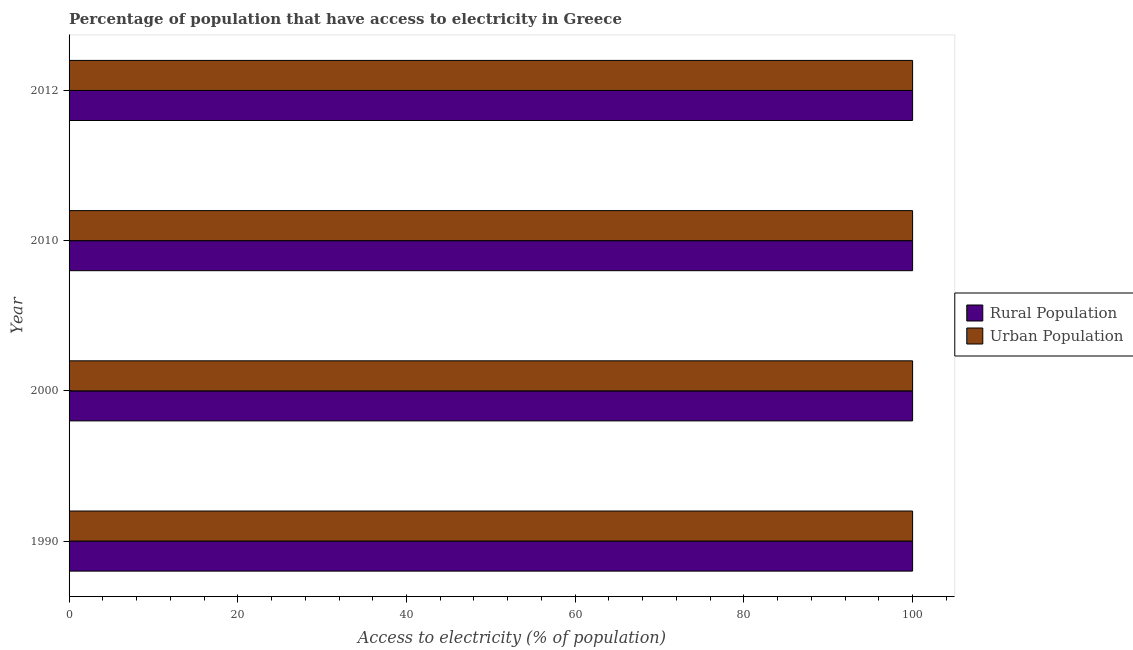How many different coloured bars are there?
Make the answer very short. 2. What is the percentage of rural population having access to electricity in 2012?
Provide a short and direct response. 100. Across all years, what is the maximum percentage of urban population having access to electricity?
Provide a short and direct response. 100. Across all years, what is the minimum percentage of rural population having access to electricity?
Your answer should be very brief. 100. What is the total percentage of rural population having access to electricity in the graph?
Keep it short and to the point. 400. What is the difference between the percentage of urban population having access to electricity in 1990 and that in 2010?
Offer a terse response. 0. What is the difference between the percentage of rural population having access to electricity in 2010 and the percentage of urban population having access to electricity in 1990?
Give a very brief answer. 0. What is the average percentage of rural population having access to electricity per year?
Provide a short and direct response. 100. In the year 1990, what is the difference between the percentage of rural population having access to electricity and percentage of urban population having access to electricity?
Make the answer very short. 0. In how many years, is the percentage of rural population having access to electricity greater than 72 %?
Make the answer very short. 4. What is the ratio of the percentage of rural population having access to electricity in 1990 to that in 2012?
Offer a very short reply. 1. What does the 1st bar from the top in 2010 represents?
Your answer should be very brief. Urban Population. What does the 2nd bar from the bottom in 1990 represents?
Your response must be concise. Urban Population. Are all the bars in the graph horizontal?
Offer a very short reply. Yes. How many years are there in the graph?
Your response must be concise. 4. What is the difference between two consecutive major ticks on the X-axis?
Offer a very short reply. 20. Are the values on the major ticks of X-axis written in scientific E-notation?
Your answer should be very brief. No. Does the graph contain any zero values?
Your answer should be very brief. No. Does the graph contain grids?
Ensure brevity in your answer.  No. Where does the legend appear in the graph?
Provide a short and direct response. Center right. How many legend labels are there?
Give a very brief answer. 2. What is the title of the graph?
Offer a very short reply. Percentage of population that have access to electricity in Greece. Does "Electricity" appear as one of the legend labels in the graph?
Offer a very short reply. No. What is the label or title of the X-axis?
Ensure brevity in your answer.  Access to electricity (% of population). What is the label or title of the Y-axis?
Keep it short and to the point. Year. What is the Access to electricity (% of population) of Rural Population in 2010?
Your answer should be compact. 100. What is the Access to electricity (% of population) in Rural Population in 2012?
Offer a terse response. 100. What is the Access to electricity (% of population) of Urban Population in 2012?
Your answer should be very brief. 100. Across all years, what is the maximum Access to electricity (% of population) in Rural Population?
Your response must be concise. 100. What is the total Access to electricity (% of population) of Rural Population in the graph?
Keep it short and to the point. 400. What is the difference between the Access to electricity (% of population) in Rural Population in 1990 and that in 2000?
Ensure brevity in your answer.  0. What is the difference between the Access to electricity (% of population) of Urban Population in 1990 and that in 2000?
Provide a short and direct response. 0. What is the difference between the Access to electricity (% of population) of Rural Population in 1990 and that in 2010?
Ensure brevity in your answer.  0. What is the difference between the Access to electricity (% of population) of Urban Population in 1990 and that in 2012?
Make the answer very short. 0. What is the difference between the Access to electricity (% of population) in Urban Population in 2000 and that in 2010?
Your answer should be very brief. 0. What is the difference between the Access to electricity (% of population) in Rural Population in 2000 and that in 2012?
Your response must be concise. 0. What is the difference between the Access to electricity (% of population) in Rural Population in 2010 and that in 2012?
Keep it short and to the point. 0. What is the difference between the Access to electricity (% of population) in Urban Population in 2010 and that in 2012?
Your response must be concise. 0. What is the difference between the Access to electricity (% of population) in Rural Population in 1990 and the Access to electricity (% of population) in Urban Population in 2010?
Give a very brief answer. 0. What is the difference between the Access to electricity (% of population) in Rural Population in 2000 and the Access to electricity (% of population) in Urban Population in 2010?
Ensure brevity in your answer.  0. What is the difference between the Access to electricity (% of population) of Rural Population in 2010 and the Access to electricity (% of population) of Urban Population in 2012?
Keep it short and to the point. 0. What is the average Access to electricity (% of population) of Rural Population per year?
Give a very brief answer. 100. What is the average Access to electricity (% of population) of Urban Population per year?
Make the answer very short. 100. In the year 1990, what is the difference between the Access to electricity (% of population) in Rural Population and Access to electricity (% of population) in Urban Population?
Offer a terse response. 0. In the year 2000, what is the difference between the Access to electricity (% of population) in Rural Population and Access to electricity (% of population) in Urban Population?
Provide a short and direct response. 0. In the year 2012, what is the difference between the Access to electricity (% of population) in Rural Population and Access to electricity (% of population) in Urban Population?
Provide a short and direct response. 0. What is the ratio of the Access to electricity (% of population) of Rural Population in 1990 to that in 2000?
Make the answer very short. 1. What is the ratio of the Access to electricity (% of population) in Urban Population in 1990 to that in 2010?
Your answer should be very brief. 1. What is the ratio of the Access to electricity (% of population) of Rural Population in 1990 to that in 2012?
Keep it short and to the point. 1. What is the ratio of the Access to electricity (% of population) of Rural Population in 2000 to that in 2010?
Give a very brief answer. 1. What is the ratio of the Access to electricity (% of population) in Urban Population in 2000 to that in 2010?
Keep it short and to the point. 1. What is the ratio of the Access to electricity (% of population) in Rural Population in 2000 to that in 2012?
Ensure brevity in your answer.  1. What is the ratio of the Access to electricity (% of population) of Urban Population in 2000 to that in 2012?
Ensure brevity in your answer.  1. What is the difference between the highest and the second highest Access to electricity (% of population) of Rural Population?
Your answer should be very brief. 0. 